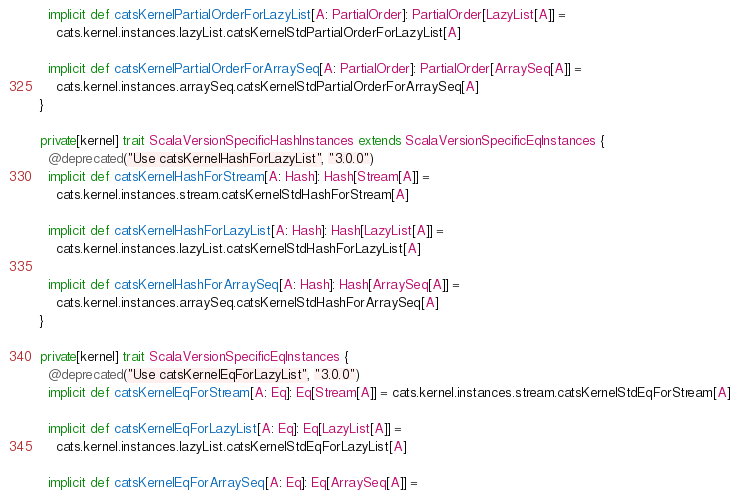Convert code to text. <code><loc_0><loc_0><loc_500><loc_500><_Scala_>  implicit def catsKernelPartialOrderForLazyList[A: PartialOrder]: PartialOrder[LazyList[A]] =
    cats.kernel.instances.lazyList.catsKernelStdPartialOrderForLazyList[A]

  implicit def catsKernelPartialOrderForArraySeq[A: PartialOrder]: PartialOrder[ArraySeq[A]] =
    cats.kernel.instances.arraySeq.catsKernelStdPartialOrderForArraySeq[A]
}

private[kernel] trait ScalaVersionSpecificHashInstances extends ScalaVersionSpecificEqInstances {
  @deprecated("Use catsKernelHashForLazyList", "3.0.0")
  implicit def catsKernelHashForStream[A: Hash]: Hash[Stream[A]] =
    cats.kernel.instances.stream.catsKernelStdHashForStream[A]

  implicit def catsKernelHashForLazyList[A: Hash]: Hash[LazyList[A]] =
    cats.kernel.instances.lazyList.catsKernelStdHashForLazyList[A]

  implicit def catsKernelHashForArraySeq[A: Hash]: Hash[ArraySeq[A]] =
    cats.kernel.instances.arraySeq.catsKernelStdHashForArraySeq[A]
}

private[kernel] trait ScalaVersionSpecificEqInstances {
  @deprecated("Use catsKernelEqForLazyList", "3.0.0")
  implicit def catsKernelEqForStream[A: Eq]: Eq[Stream[A]] = cats.kernel.instances.stream.catsKernelStdEqForStream[A]

  implicit def catsKernelEqForLazyList[A: Eq]: Eq[LazyList[A]] =
    cats.kernel.instances.lazyList.catsKernelStdEqForLazyList[A]

  implicit def catsKernelEqForArraySeq[A: Eq]: Eq[ArraySeq[A]] =</code> 